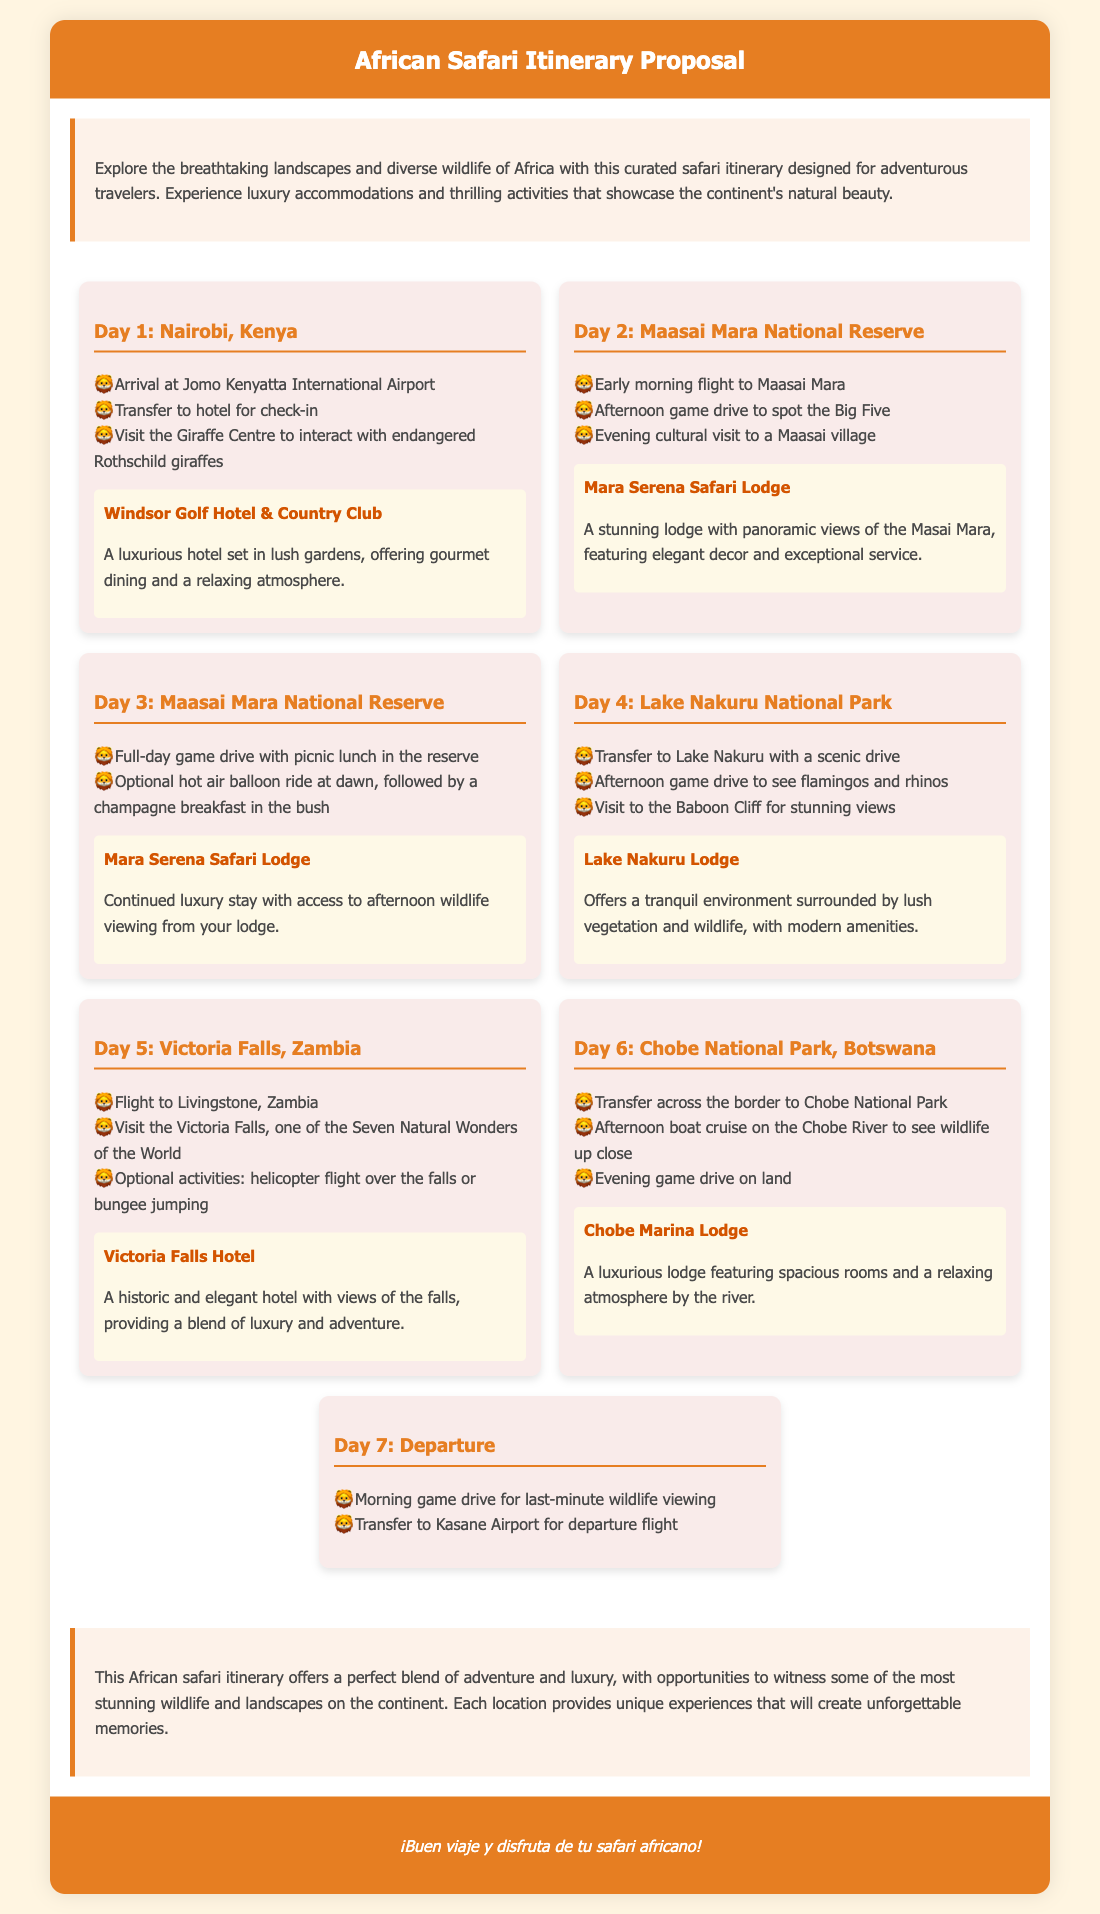What is the starting location of the itinerary? The itinerary begins with the arrival in Nairobi, Kenya.
Answer: Nairobi, Kenya What is the accommodation in Maasai Mara National Reserve? The itinerary specifies that the accommodation while in Maasai Mara is Mara Serena Safari Lodge.
Answer: Mara Serena Safari Lodge How many days does the safari last? The itinerary outlines activities for a total of 7 days.
Answer: 7 days What optional activity is offered at Victoria Falls? The itinerary mentions a helicopter flight over the falls as an optional activity.
Answer: Helicopter flight Which national park is visited after Maasai Mara? The itinerary indicates that the next destination after Maasai Mara is Lake Nakuru National Park.
Answer: Lake Nakuru National Park What activity is included on Day 3? The itinerary states that a full-day game drive with picnic lunch is included on Day 3.
Answer: Full-day game drive with picnic lunch What kind of dining experience does the Windsor Golf Hotel & Country Club offer? The document describes the dining experience at Windsor Golf Hotel & Country Club as gourmet dining.
Answer: Gourmet dining What is the special feature of the Chobe Marina Lodge? The itinerary highlights the lodge as featuring spacious rooms and a relaxing atmosphere by the river.
Answer: Spacious rooms and relaxing atmosphere What is the main attraction of Victoria Falls mentioned in the itinerary? The itinerary refers to the Victoria Falls as one of the Seven Natural Wonders of the World.
Answer: One of the Seven Natural Wonders of the World 